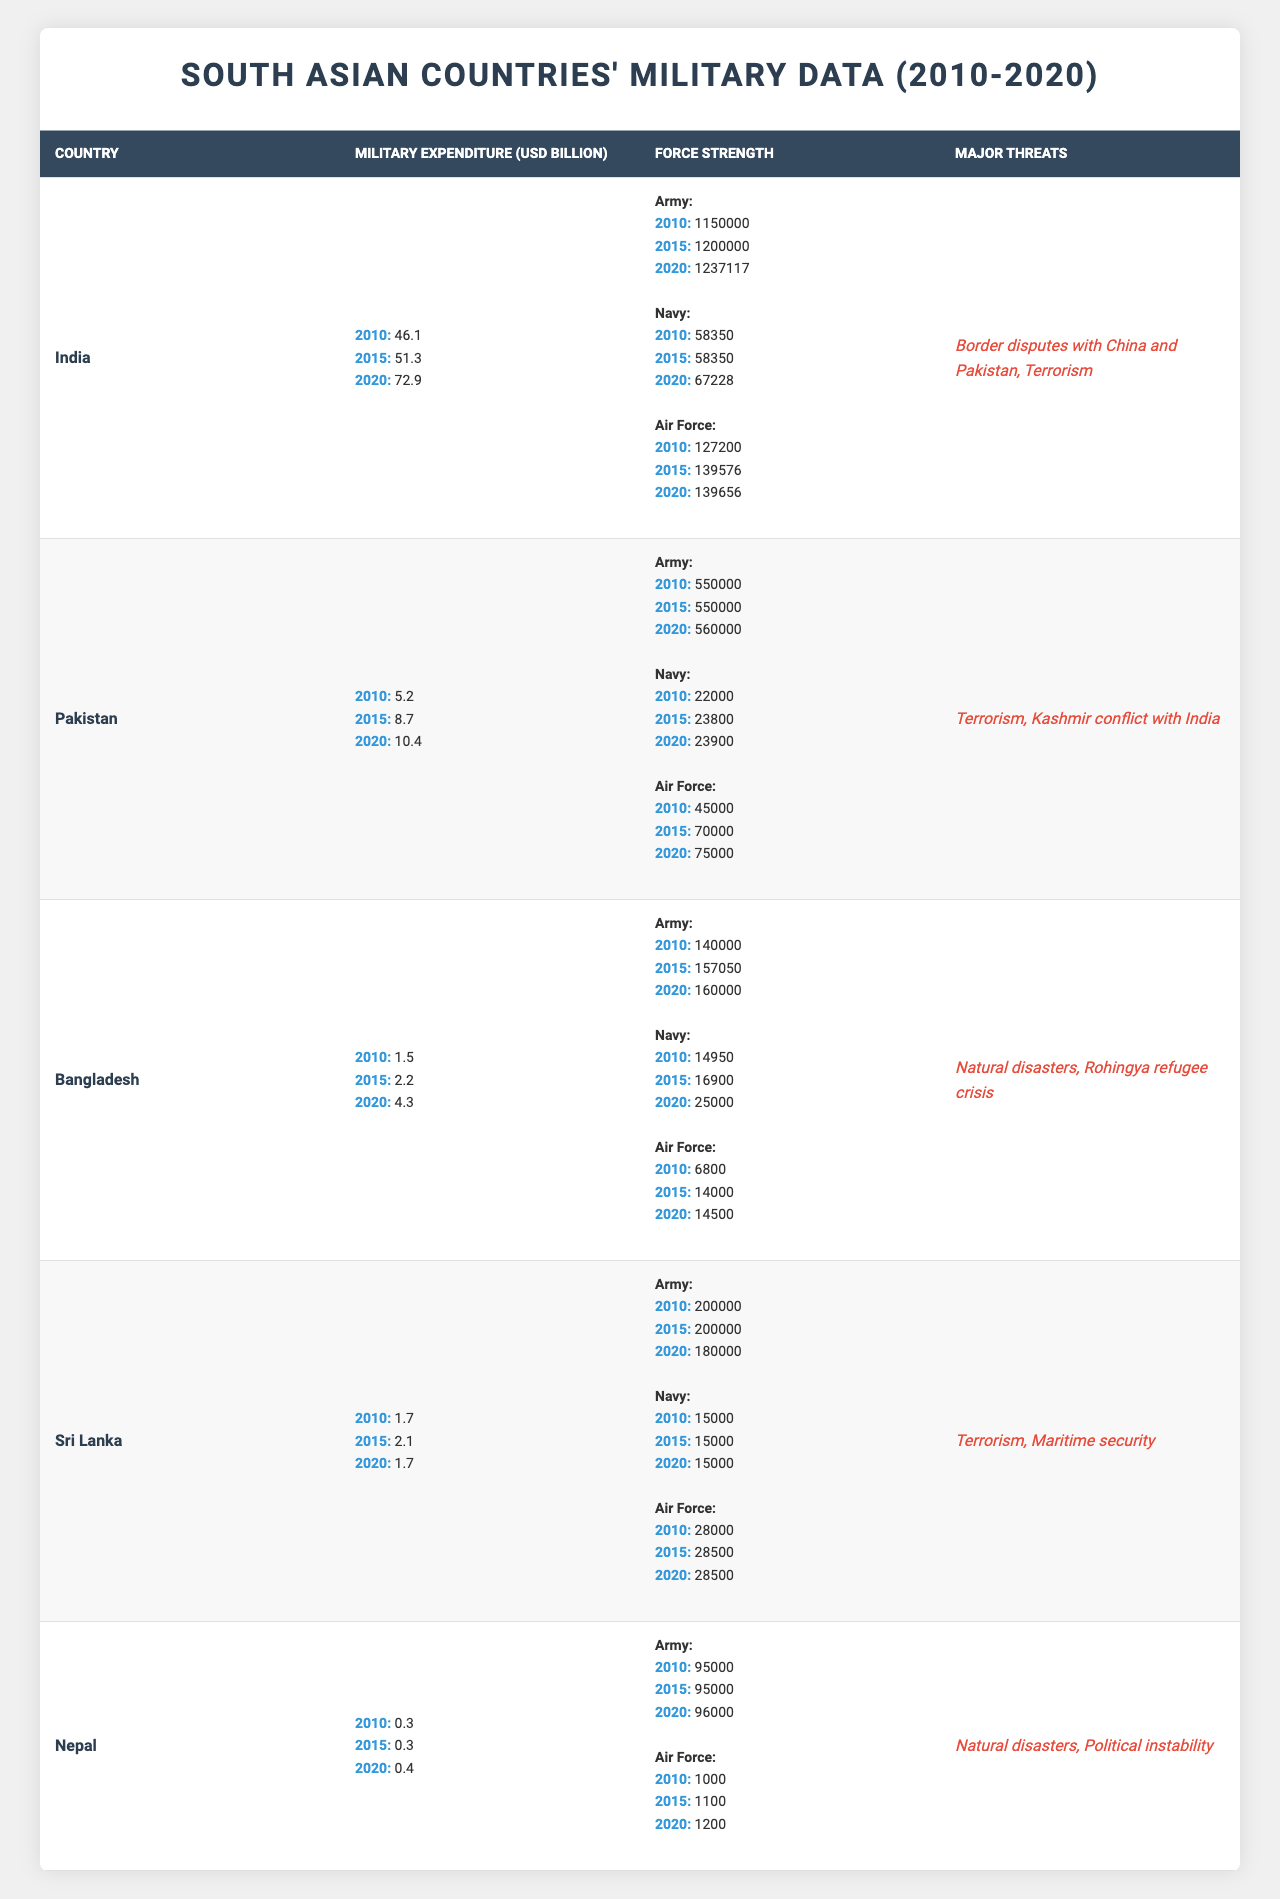What was India's military expenditure in 2020? By observing the "Military Expenditure (USD Billion)" column for India in the table, the value listed for 2020 is 72.9 billion USD.
Answer: 72.9 billion USD Which country had the highest military expenditure in 2015? In the year 2015, the military expenditures for the countries are: India (51.3), Pakistan (8.7), Bangladesh (2.2), Sri Lanka (2.1), and Nepal (0.3). India had the highest expenditure at 51.3 billion USD.
Answer: India How much did Pakistan's military expenditure increase from 2010 to 2020? The military expenditure for Pakistan in 2010 was 5.2 billion USD and in 2020 it was 10.4 billion USD. The increase is calculated as 10.4 - 5.2 = 5.2 billion USD.
Answer: 5.2 billion USD What is the average military expenditure of South Asian countries in 2010? The military expenditures in 2010 were: India (46.1), Pakistan (5.2), Bangladesh (1.5), Sri Lanka (1.7), and Nepal (0.3). Summing these values gives 54.8 billion USD. There are 5 countries, so the average is 54.8 / 5 = 10.96 billion USD.
Answer: 10.96 billion USD What was the total Army strength of all countries in 2020? The Army strengths in 2020 were: India (1,237,117), Pakistan (560,000), Bangladesh (160,000), Sri Lanka (180,000), and Nepal (96,000). Summing these values gives 1,237,117 + 560,000 + 160,000 + 180,000 + 96,000 = 2,233,117.
Answer: 2,233,117 Did Bangladesh’s military expenditure decrease from 2015 to 2020? In 2015, Bangladesh's military expenditure was 2.2 billion USD and in 2020 it was 4.3 billion USD. Since 4.3 is greater than 2.2, the expenditure did not decrease; it increased.
Answer: No Which country's Air Force showed the smallest change from 2010 to 2020? The Air Force strengths for each country in 2010 and 2020 show the following changes: India (from 127,200 to 139,656), Pakistan (from 45,000 to 75,000), Bangladesh (from 6,800 to 14,500), Sri Lanka (from 28,000 to 28,500), and Nepal (from 1,000 to 1,200). The smallest change is Sri Lanka with an increase of 500.
Answer: Sri Lanka What major threats does Nepal face according to the table? The Major Threats listed for Nepal are "Natural disasters" and "Political instability".
Answer: Natural disasters, Political instability In which year did the Indian Navy have the highest reported strength? The Navy strengths for India in 2010, 2015, and 2020 are: 58,350, 58,350, and 67,228 respectively. The highest reported strength is in 2020 with 67,228.
Answer: 2020 Was Sri Lanka's military expenditure higher in 2015 compared to 2020? Sri Lanka's military expenditure was 2.1 billion USD in 2015 and 1.7 billion USD in 2020. Since 1.7 is less than 2.1, the expenditure in 2020 was lower.
Answer: Yes 